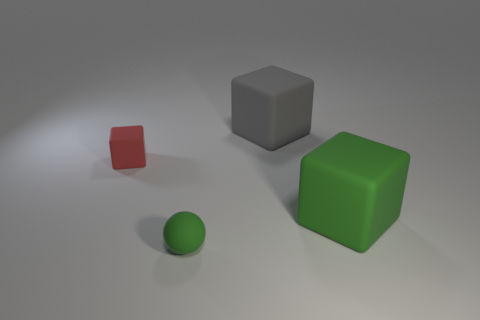Subtract all brown blocks. Subtract all yellow cylinders. How many blocks are left? 3 Add 1 large rubber cubes. How many objects exist? 5 Subtract all blocks. How many objects are left? 1 Subtract 0 blue cylinders. How many objects are left? 4 Subtract all small purple rubber cylinders. Subtract all gray matte things. How many objects are left? 3 Add 3 matte spheres. How many matte spheres are left? 4 Add 4 small purple shiny blocks. How many small purple shiny blocks exist? 4 